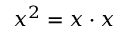<formula> <loc_0><loc_0><loc_500><loc_500>x ^ { 2 } = x \cdot x</formula> 